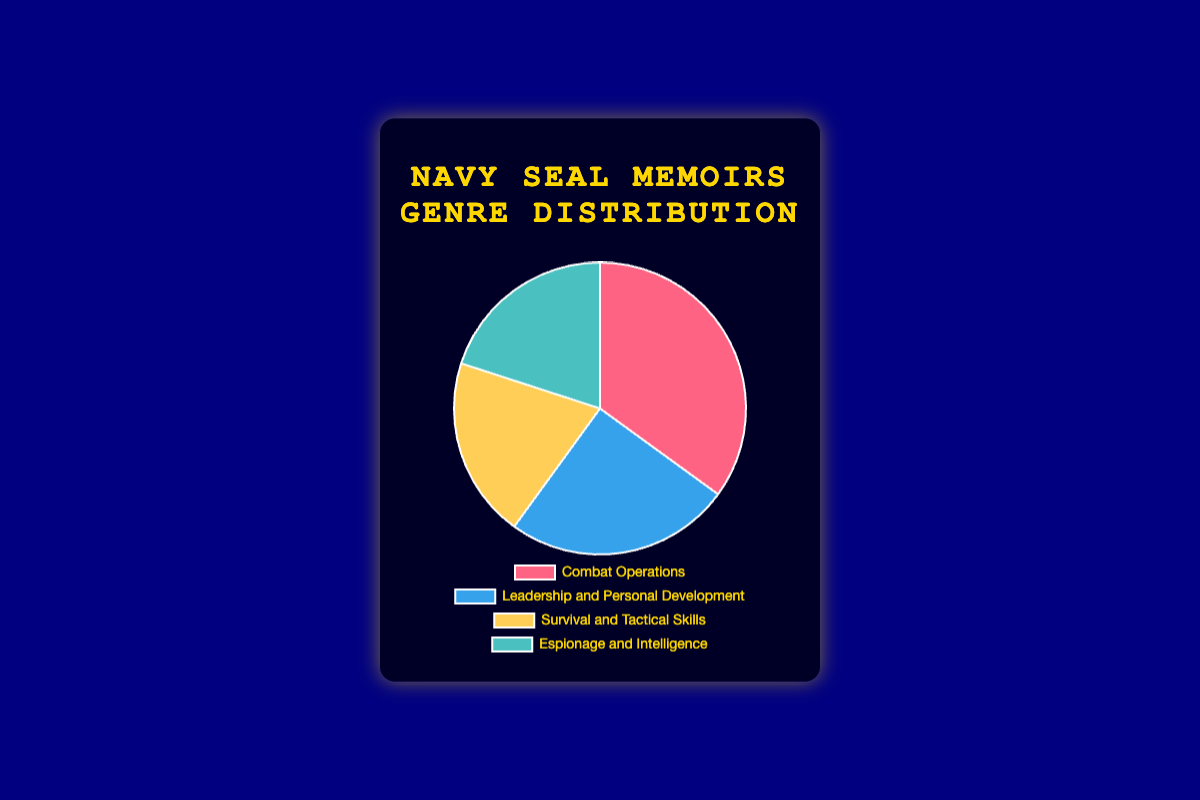What percentage of Navy SEAL memoirs are about Combat Operations? Look at the "Combat Operations" section in the pie chart and read the label that indicates the percentage. It's denoted as 35%.
Answer: 35% How do Leadership and Personal Development compare to Survival and Tactical Skills in terms of their percentage distribution? Compare the percentages of "Leadership and Personal Development" (25%) and "Survival and Tactical Skills" (20%) from the pie chart. Leadership and Personal Development have a higher percentage than Survival and Tactical Skills.
Answer: Leadership and Personal Development have a higher percentage Which two genres have the same percentage distribution? Look at the pie chart and identify the sections with the same percentage. "Survival and Tactical Skills" and "Espionage and Intelligence" both show 20%.
Answer: Survival and Tactical Skills and Espionage and Intelligence Sum up the percentage distribution of genres that focus on skill-related topics. Add the percentages of "Survival and Tactical Skills" (20%) and "Espionage and Intelligence" (20%) from the pie chart. The sum is 20% + 20% = 40%.
Answer: 40% What is the total percentage of memoirs that do not focus on Combat Operations? Subtract the percentage of "Combat Operations" (35%) from 100%. The calculation is 100% - 35% = 65%.
Answer: 65% If Leadership and Personal Development memoirs made up 30% of the total instead, what would be the difference from their current percentage? Calculate the difference between the hypothetical percentage (30%) and the current percentage (25%). The difference is 30% - 25% = 5%.
Answer: 5% Which genre has the largest section in the pie chart, and what is its visual representation color? Identify the section with the largest percentage, which is "Combat Operations" (35%). Check the color associated with it on the pie chart, which is likely red based on the order of colors.
Answer: Combat Operations, red What is the average percentage of genres other than Combat Operations? Add the percentages of the other three genres and divide by the number of genres. (25% + 20% + 20%) / 3 = 65% / 3 ≈ 21.67%.
Answer: 21.67% Which genre would need 10% more to equal the percentage of Combat Operations? Compare 35% (Combat Operations) with the other genres and find the genre that would need 10% more to reach 35%. Survival and Tactical Skills are at 20%, so 35% - 20% = 15%. Thus, neither genre needs exactly 10%.
Answer: None 